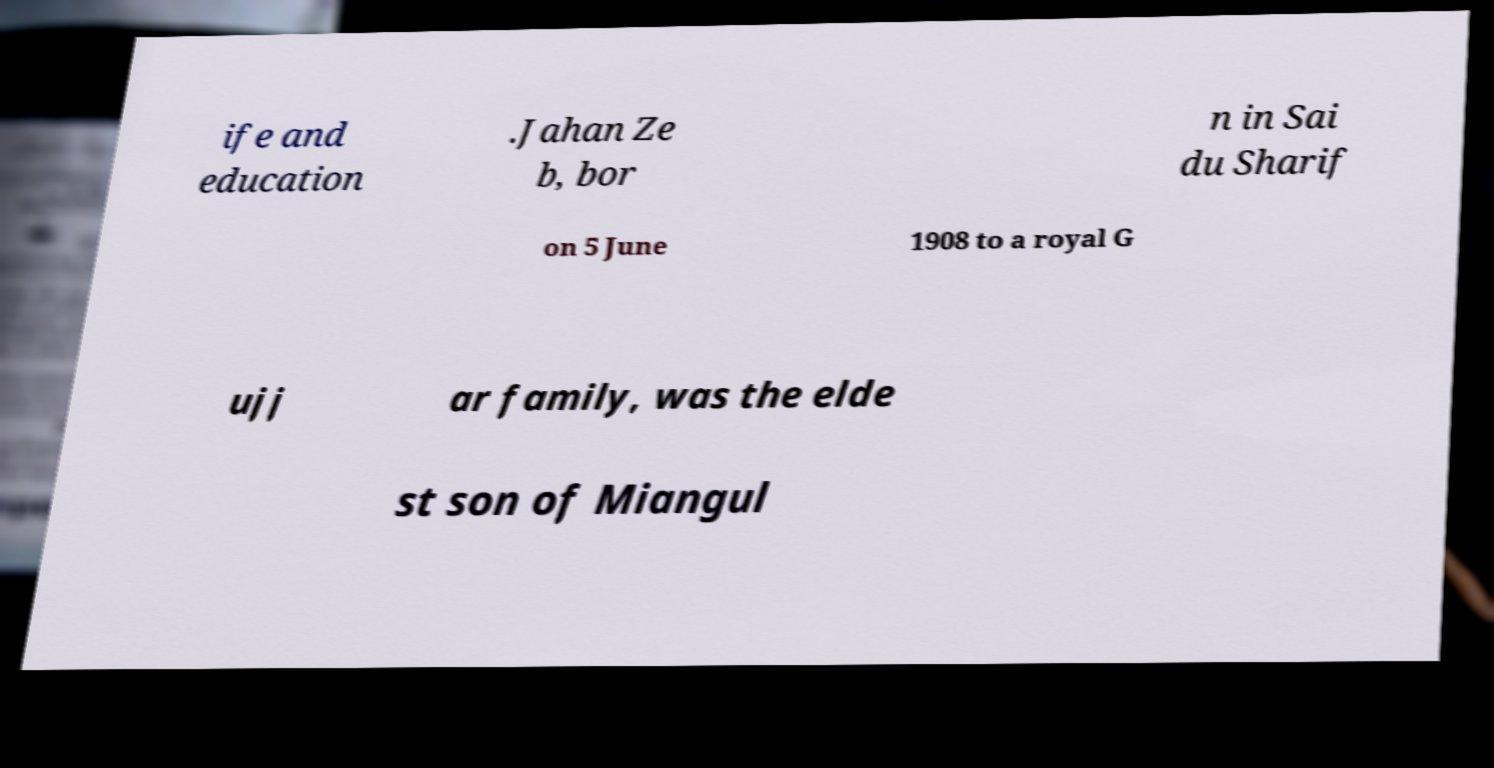Could you assist in decoding the text presented in this image and type it out clearly? ife and education .Jahan Ze b, bor n in Sai du Sharif on 5 June 1908 to a royal G ujj ar family, was the elde st son of Miangul 